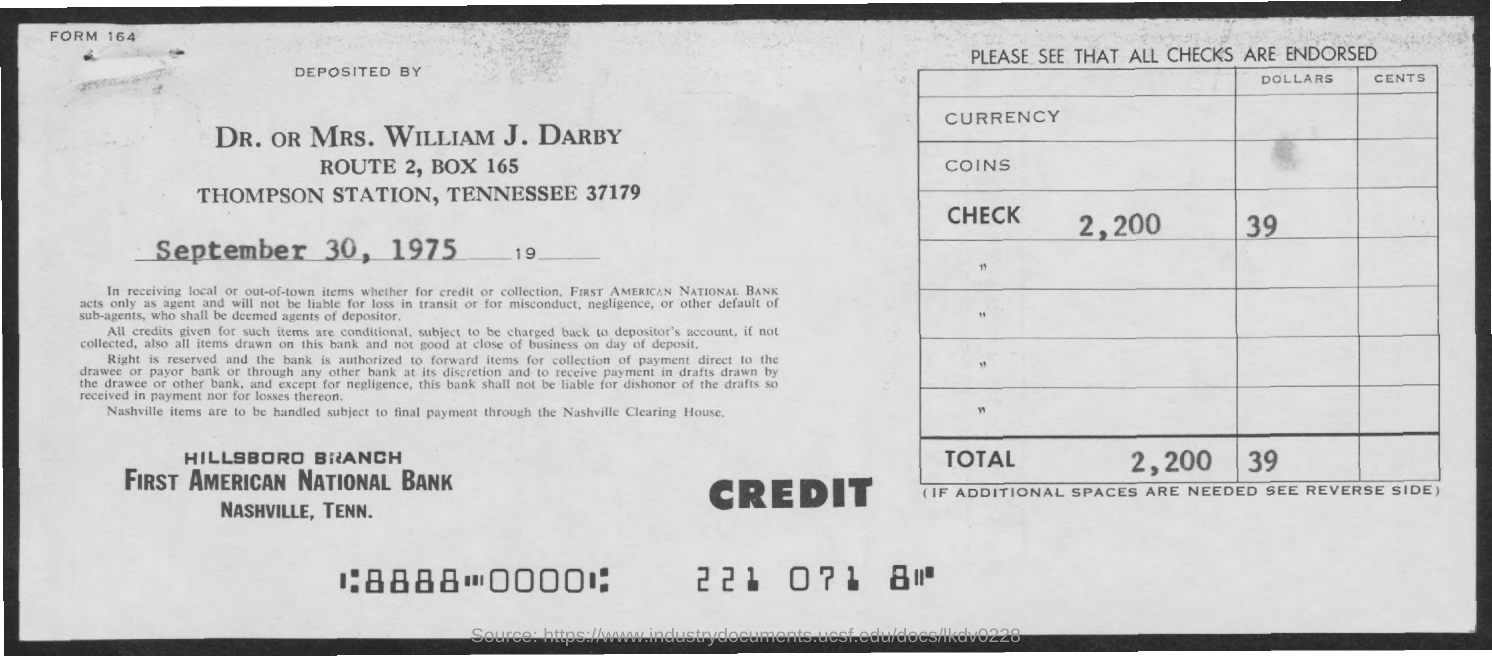The cheque is deposited by whom ?
Offer a terse response. Dr. or mrs. william j. darby. What is the name of the station mentioned ?
Make the answer very short. Thompson station. What is the name of the bank
Your answer should be compact. First American National bank. In which state and city First American National Bank is located
Give a very brief answer. Nashville, tenn. What is the date mentioned ?
Provide a succinct answer. September 30 , 1975. What is the form no ?
Make the answer very short. 164. 